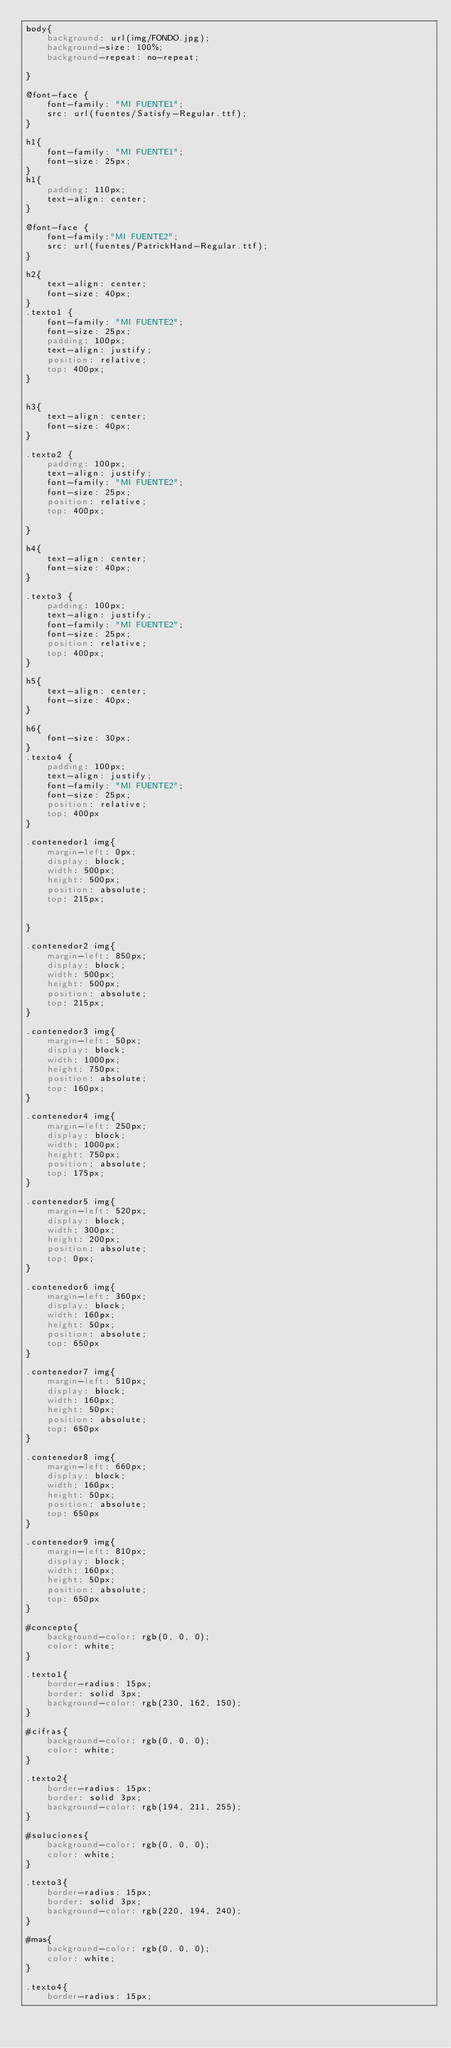<code> <loc_0><loc_0><loc_500><loc_500><_CSS_>body{
    background: url(img/FONDO.jpg);
    background-size: 100%;
    background-repeat: no-repeat;
    
}

@font-face {
    font-family: "MI FUENTE1";
    src: url(fuentes/Satisfy-Regular.ttf);
}

h1{
    font-family: "MI FUENTE1";
    font-size: 25px;
}
h1{
    padding: 110px;
    text-align: center;
}

@font-face {
    font-family:"MI FUENTE2";
    src: url(fuentes/PatrickHand-Regular.ttf);
}

h2{
    text-align: center;
    font-size: 40px;
}
.texto1 {
    font-family: "MI FUENTE2";
    font-size: 25px;
    padding: 100px;
    text-align: justify;
    position: relative;
    top: 400px;
}


h3{
    text-align: center;
    font-size: 40px;
}

.texto2 {
    padding: 100px;
    text-align: justify;
    font-family: "MI FUENTE2";
    font-size: 25px;
    position: relative;
    top: 400px;

}

h4{
    text-align: center;
    font-size: 40px;
}

.texto3 {
    padding: 100px;
    text-align: justify;
    font-family: "MI FUENTE2";
    font-size: 25px;
    position: relative;
    top: 400px;
}

h5{
    text-align: center;
    font-size: 40px;
}

h6{
    font-size: 30px;
}
.texto4 {
    padding: 100px;
    text-align: justify;
    font-family: "MI FUENTE2";
    font-size: 25px;
    position: relative;
    top: 400px
}

.contenedor1 img{
    margin-left: 0px;
    display: block;
    width: 500px;
    height: 500px;
    position: absolute;
    top: 215px;
    

}

.contenedor2 img{
    margin-left: 850px;
    display: block;
    width: 500px;
    height: 500px;
    position: absolute;
    top: 215px;
}

.contenedor3 img{
    margin-left: 50px;
    display: block;
    width: 1000px;
    height: 750px;
    position: absolute;
    top: 160px;
}

.contenedor4 img{
    margin-left: 250px;
    display: block;
    width: 1000px;
    height: 750px;
    position: absolute;
    top: 175px;
}

.contenedor5 img{
    margin-left: 520px;
    display: block;
    width: 300px;
    height: 200px;
    position: absolute;
    top: 0px;
}

.contenedor6 img{
    margin-left: 360px;
    display: block;
    width: 160px;
    height: 50px;
    position: absolute;
    top: 650px
}

.contenedor7 img{
    margin-left: 510px;
    display: block;
    width: 160px;
    height: 50px;
    position: absolute;
    top: 650px
}

.contenedor8 img{
    margin-left: 660px;
    display: block;
    width: 160px;
    height: 50px;
    position: absolute;
    top: 650px
}

.contenedor9 img{
    margin-left: 810px;
    display: block;
    width: 160px;
    height: 50px;
    position: absolute;
    top: 650px
}

#concepto{
    background-color: rgb(0, 0, 0);
    color: white;
}

.texto1{
    border-radius: 15px;
    border: solid 3px;
    background-color: rgb(230, 162, 150);
}

#cifras{
    background-color: rgb(0, 0, 0);
    color: white;
}

.texto2{
    border-radius: 15px;
    border: solid 3px;
    background-color: rgb(194, 211, 255);
}

#soluciones{
    background-color: rgb(0, 0, 0);
    color: white;
}

.texto3{
    border-radius: 15px;
    border: solid 3px;
    background-color: rgb(220, 194, 240);
}

#mas{
    background-color: rgb(0, 0, 0);
    color: white;
}

.texto4{
    border-radius: 15px;</code> 